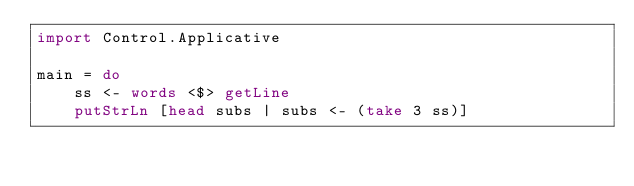<code> <loc_0><loc_0><loc_500><loc_500><_Haskell_>import Control.Applicative

main = do
    ss <- words <$> getLine
    putStrLn [head subs | subs <- (take 3 ss)]</code> 